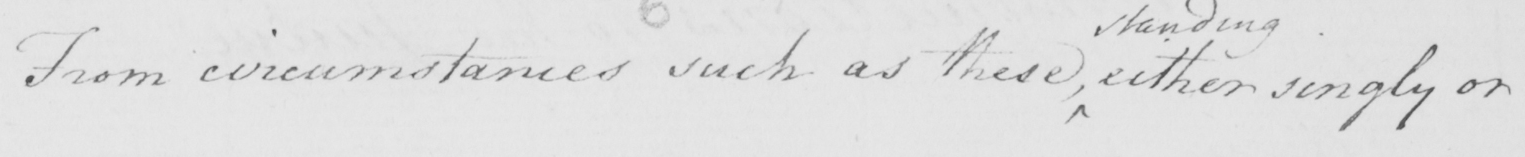What text is written in this handwritten line? From circumstances such as these either singly or 